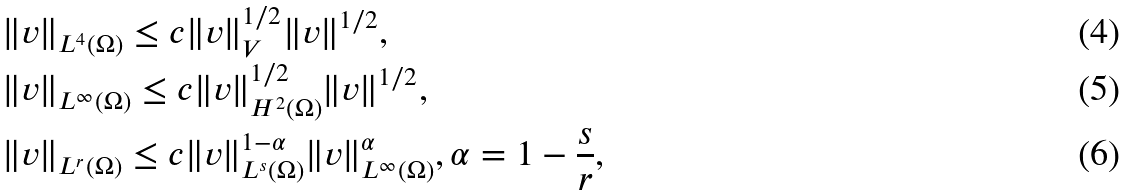<formula> <loc_0><loc_0><loc_500><loc_500>& \| v \| _ { L ^ { 4 } ( \Omega ) } \leq c \| v \| _ { V } ^ { 1 / 2 } \| v \| ^ { 1 / 2 } , \\ & \| v \| _ { L ^ { \infty } ( \Omega ) } \leq c \| v \| _ { H ^ { 2 } ( \Omega ) } ^ { 1 / 2 } \| v \| ^ { 1 / 2 } , \\ & \| v \| _ { L ^ { r } ( \Omega ) } \leq c \| v \| _ { L ^ { s } ( \Omega ) } ^ { 1 - \alpha } \| v \| _ { L ^ { \infty } ( \Omega ) } ^ { \alpha } , \alpha = 1 - \frac { s } { r } ,</formula> 